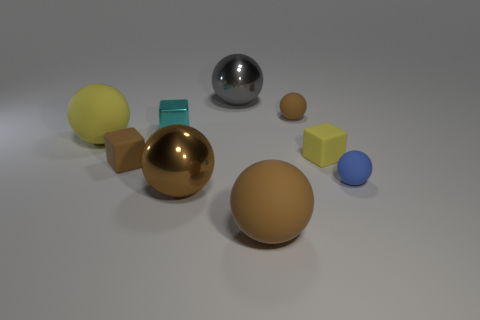There is a tiny metallic block; is it the same color as the tiny rubber ball in front of the large yellow matte object?
Ensure brevity in your answer.  No. There is a matte cube that is left of the large metal sphere behind the small blue object; what is its color?
Ensure brevity in your answer.  Brown. There is a brown rubber object in front of the large shiny thing in front of the brown cube; are there any large metallic balls that are in front of it?
Offer a terse response. No. What color is the block that is the same material as the small yellow object?
Your answer should be very brief. Brown. How many balls have the same material as the small brown cube?
Your answer should be very brief. 4. Does the small brown sphere have the same material as the gray object that is on the right side of the brown cube?
Give a very brief answer. No. How many things are brown objects that are right of the cyan cube or brown rubber cubes?
Provide a short and direct response. 4. There is a matte block that is behind the tiny matte cube that is to the left of the large rubber sphere right of the gray shiny object; what size is it?
Your response must be concise. Small. Is there any other thing that has the same shape as the large yellow object?
Your answer should be very brief. Yes. There is a yellow object on the right side of the yellow thing left of the cyan block; what is its size?
Your response must be concise. Small. 